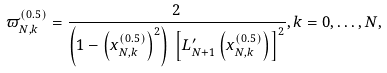Convert formula to latex. <formula><loc_0><loc_0><loc_500><loc_500>{ \varpi _ { N , k } ^ { ( 0 . 5 ) } } = \frac { 2 } { { \left ( { 1 - { { \left ( { { x _ { N , k } ^ { ( 0 . 5 ) } } } \right ) } ^ { 2 } } } \right ) \, { { \left [ { { L ^ { \prime } _ { N + 1 } } \left ( { x _ { N , k } ^ { ( 0 . 5 ) } } \right ) } \right ] } ^ { 2 } } } } , k = 0 , \dots , N ,</formula> 